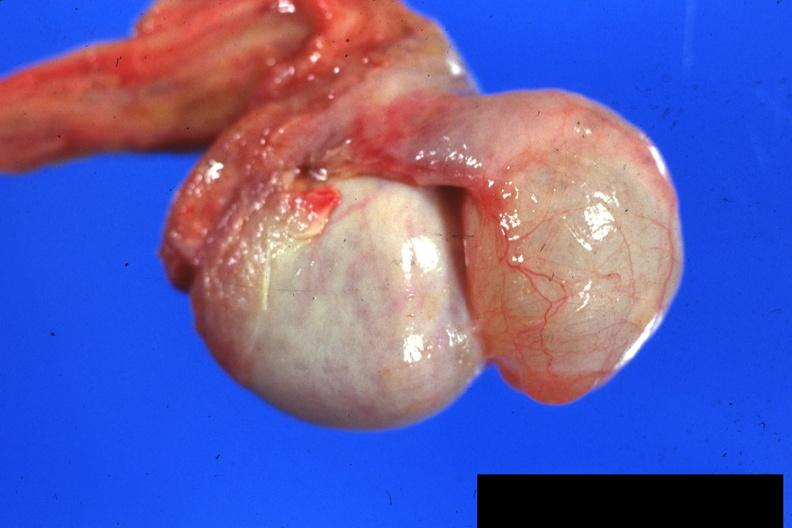s cytomegalovirus present?
Answer the question using a single word or phrase. No 